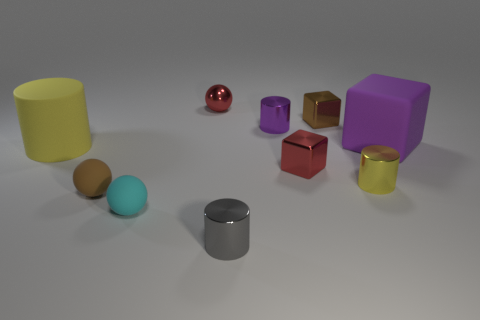How big is the brown thing that is behind the large rubber object right of the metallic block that is behind the large matte cube?
Keep it short and to the point. Small. Are there more purple metal cylinders that are right of the yellow shiny thing than gray metal things?
Your answer should be very brief. No. Are there any small yellow shiny balls?
Ensure brevity in your answer.  No. What number of brown spheres have the same size as the gray metallic object?
Provide a succinct answer. 1. Is the number of small yellow objects that are behind the small red shiny cube greater than the number of matte cubes that are left of the cyan rubber sphere?
Ensure brevity in your answer.  No. There is a yellow thing that is the same size as the cyan rubber thing; what is its material?
Your answer should be compact. Metal. What is the shape of the big purple rubber object?
Your answer should be compact. Cube. How many red objects are tiny cylinders or tiny matte cylinders?
Provide a succinct answer. 0. What is the size of the cyan ball that is the same material as the small brown ball?
Offer a terse response. Small. Does the large object in front of the large purple matte cube have the same material as the yellow cylinder in front of the big yellow cylinder?
Your response must be concise. No. 